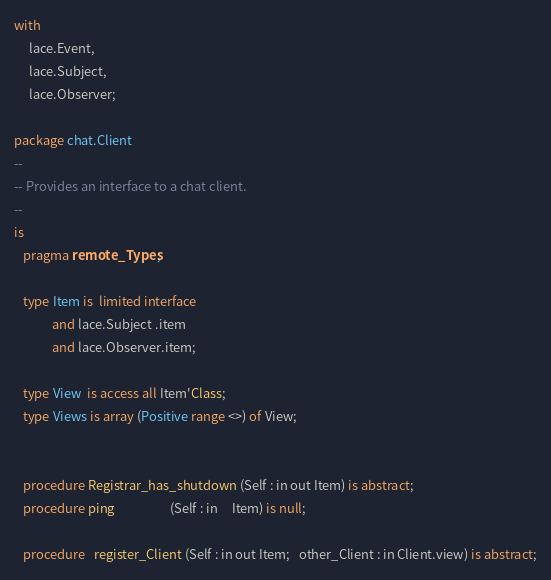Convert code to text. <code><loc_0><loc_0><loc_500><loc_500><_Ada_>with
     lace.Event,
     lace.Subject,
     lace.Observer;

package chat.Client
--
-- Provides an interface to a chat client.
--
is
   pragma remote_Types;

   type Item is  limited interface
             and lace.Subject .item
             and lace.Observer.item;

   type View  is access all Item'Class;
   type Views is array (Positive range <>) of View;


   procedure Registrar_has_shutdown (Self : in out Item) is abstract;
   procedure ping                   (Self : in     Item) is null;

   procedure   register_Client (Self : in out Item;   other_Client : in Client.view) is abstract;
</code> 